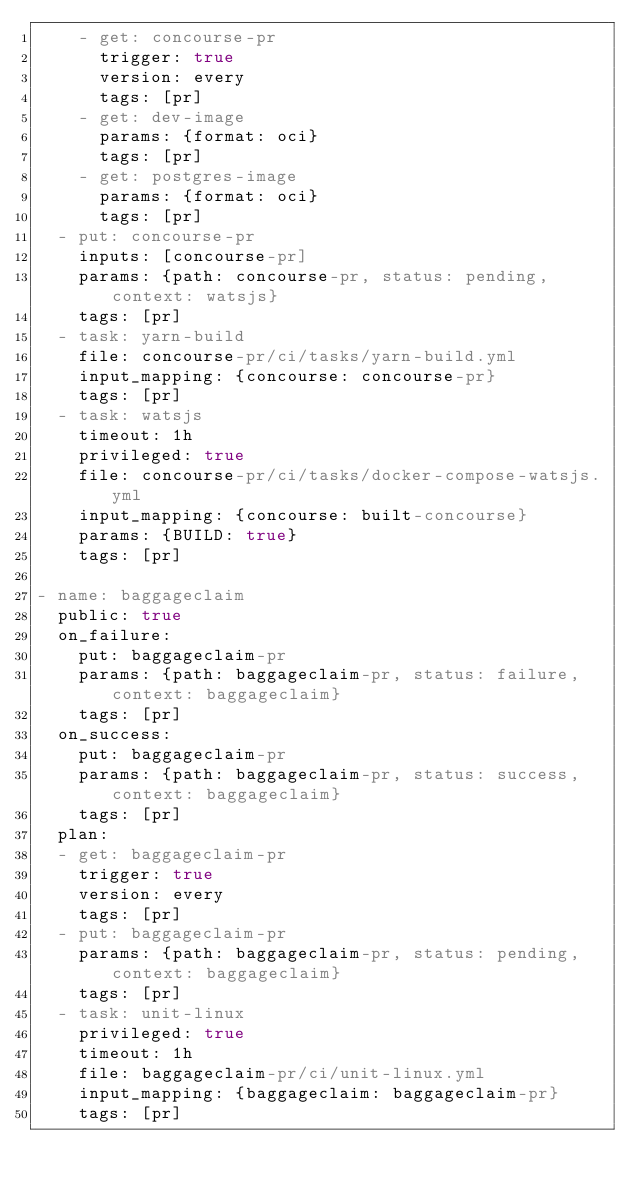<code> <loc_0><loc_0><loc_500><loc_500><_YAML_>    - get: concourse-pr
      trigger: true
      version: every
      tags: [pr]
    - get: dev-image
      params: {format: oci}
      tags: [pr]
    - get: postgres-image
      params: {format: oci}
      tags: [pr]
  - put: concourse-pr
    inputs: [concourse-pr]
    params: {path: concourse-pr, status: pending, context: watsjs}
    tags: [pr]
  - task: yarn-build
    file: concourse-pr/ci/tasks/yarn-build.yml
    input_mapping: {concourse: concourse-pr}
    tags: [pr]
  - task: watsjs
    timeout: 1h
    privileged: true
    file: concourse-pr/ci/tasks/docker-compose-watsjs.yml
    input_mapping: {concourse: built-concourse}
    params: {BUILD: true}
    tags: [pr]

- name: baggageclaim
  public: true
  on_failure:
    put: baggageclaim-pr
    params: {path: baggageclaim-pr, status: failure, context: baggageclaim}
    tags: [pr]
  on_success:
    put: baggageclaim-pr
    params: {path: baggageclaim-pr, status: success, context: baggageclaim}
    tags: [pr]
  plan:
  - get: baggageclaim-pr
    trigger: true
    version: every
    tags: [pr]
  - put: baggageclaim-pr
    params: {path: baggageclaim-pr, status: pending, context: baggageclaim}
    tags: [pr]
  - task: unit-linux
    privileged: true
    timeout: 1h
    file: baggageclaim-pr/ci/unit-linux.yml
    input_mapping: {baggageclaim: baggageclaim-pr}
    tags: [pr]
</code> 